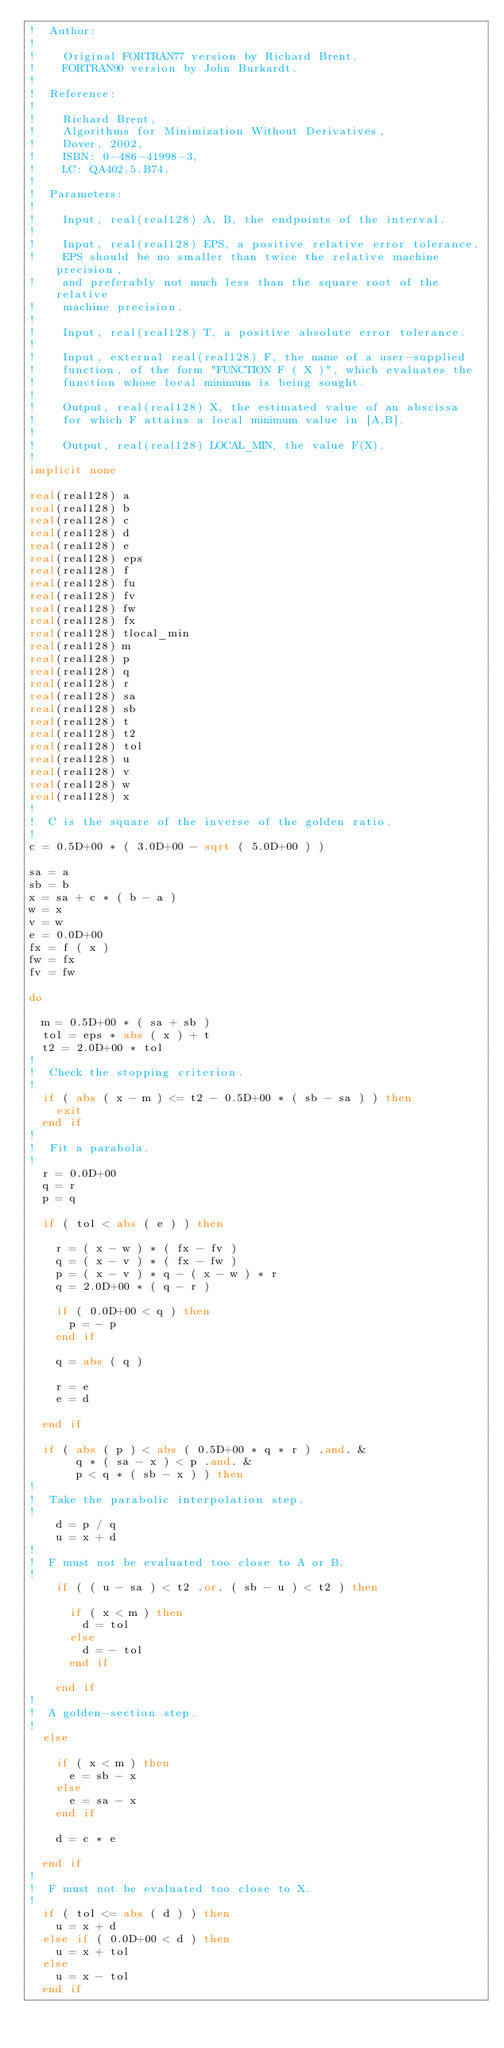<code> <loc_0><loc_0><loc_500><loc_500><_FORTRAN_>!  Author:
!
!    Original FORTRAN77 version by Richard Brent.
!    FORTRAN90 version by John Burkardt.
!
!  Reference:
!
!    Richard Brent,
!    Algorithms for Minimization Without Derivatives,
!    Dover, 2002,
!    ISBN: 0-486-41998-3,
!    LC: QA402.5.B74.
!
!  Parameters:
!
!    Input, real(real128) A, B, the endpoints of the interval.
!
!    Input, real(real128) EPS, a positive relative error tolerance.
!    EPS should be no smaller than twice the relative machine precision,
!    and preferably not much less than the square root of the relative
!    machine precision.
!
!    Input, real(real128) T, a positive absolute error tolerance.
!
!    Input, external real(real128) F, the name of a user-supplied
!    function, of the form "FUNCTION F ( X )", which evaluates the
!    function whose local minimum is being sought.
!
!    Output, real(real128) X, the estimated value of an abscissa
!    for which F attains a local minimum value in [A,B].
!
!    Output, real(real128) LOCAL_MIN, the value F(X).
!
implicit none

real(real128) a
real(real128) b
real(real128) c
real(real128) d
real(real128) e
real(real128) eps
real(real128) f
real(real128) fu
real(real128) fv
real(real128) fw
real(real128) fx
real(real128) tlocal_min
real(real128) m
real(real128) p
real(real128) q
real(real128) r
real(real128) sa
real(real128) sb
real(real128) t
real(real128) t2
real(real128) tol
real(real128) u
real(real128) v
real(real128) w
real(real128) x
!
!  C is the square of the inverse of the golden ratio.
!
c = 0.5D+00 * ( 3.0D+00 - sqrt ( 5.0D+00 ) )

sa = a
sb = b
x = sa + c * ( b - a )
w = x
v = w
e = 0.0D+00
fx = f ( x )
fw = fx
fv = fw

do

  m = 0.5D+00 * ( sa + sb )
  tol = eps * abs ( x ) + t
  t2 = 2.0D+00 * tol
!
!  Check the stopping criterion.
!
  if ( abs ( x - m ) <= t2 - 0.5D+00 * ( sb - sa ) ) then
    exit
  end if
!
!  Fit a parabola.
!
  r = 0.0D+00
  q = r
  p = q

  if ( tol < abs ( e ) ) then

    r = ( x - w ) * ( fx - fv )
    q = ( x - v ) * ( fx - fw )
    p = ( x - v ) * q - ( x - w ) * r
    q = 2.0D+00 * ( q - r )

    if ( 0.0D+00 < q ) then
      p = - p
    end if

    q = abs ( q )

    r = e
    e = d

  end if

  if ( abs ( p ) < abs ( 0.5D+00 * q * r ) .and. &
       q * ( sa - x ) < p .and. &
       p < q * ( sb - x ) ) then
!
!  Take the parabolic interpolation step.
!
    d = p / q
    u = x + d
!
!  F must not be evaluated too close to A or B.
!
    if ( ( u - sa ) < t2 .or. ( sb - u ) < t2 ) then

      if ( x < m ) then
        d = tol
      else
        d = - tol
      end if

    end if
!
!  A golden-section step.
!
  else

    if ( x < m ) then
      e = sb - x
    else
      e = sa - x
    end if

    d = c * e

  end if
!
!  F must not be evaluated too close to X.
!
  if ( tol <= abs ( d ) ) then
    u = x + d
  else if ( 0.0D+00 < d ) then
    u = x + tol
  else
    u = x - tol
  end if
</code> 